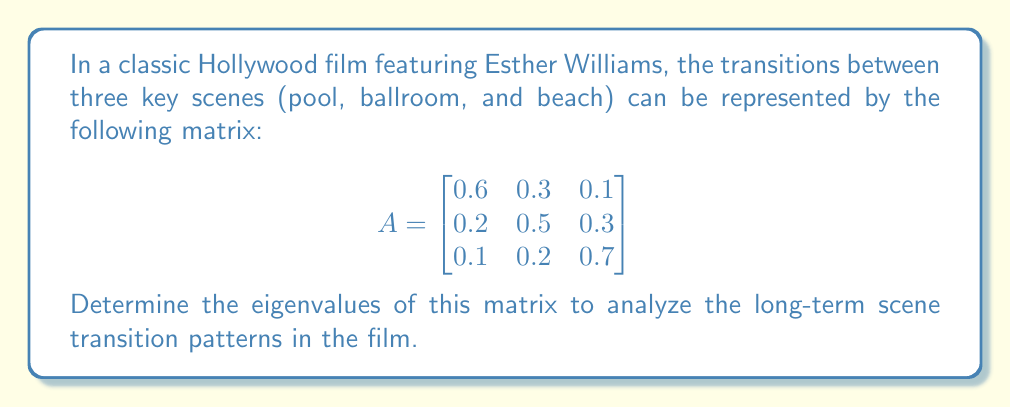Help me with this question. To find the eigenvalues of matrix A, we need to solve the characteristic equation:

1) First, we set up the equation $det(A - \lambda I) = 0$, where $I$ is the 3x3 identity matrix:

   $$det\begin{pmatrix}
   0.6-\lambda & 0.3 & 0.1 \\
   0.2 & 0.5-\lambda & 0.3 \\
   0.1 & 0.2 & 0.7-\lambda
   \end{pmatrix} = 0$$

2) Expand the determinant:
   $$(0.6-\lambda)[(0.5-\lambda)(0.7-\lambda) - 0.06] - 0.3[0.2(0.7-\lambda) - 0.03] + 0.1[0.2(0.5-\lambda) - 0.06] = 0$$

3) Simplify:
   $$\lambda^3 - 1.8\lambda^2 + 0.83\lambda - 0.1 = 0$$

4) This cubic equation can be solved using the cubic formula or numerical methods. Using a computer algebra system, we find the roots:

   $\lambda_1 = 1$
   $\lambda_2 \approx 0.5245$
   $\lambda_3 \approx 0.2755$

5) These are the eigenvalues of the matrix A.

The eigenvalue 1 represents the steady-state distribution of scenes, while the other two eigenvalues indicate how quickly the system converges to this steady state.
Answer: $\lambda_1 = 1$, $\lambda_2 \approx 0.5245$, $\lambda_3 \approx 0.2755$ 